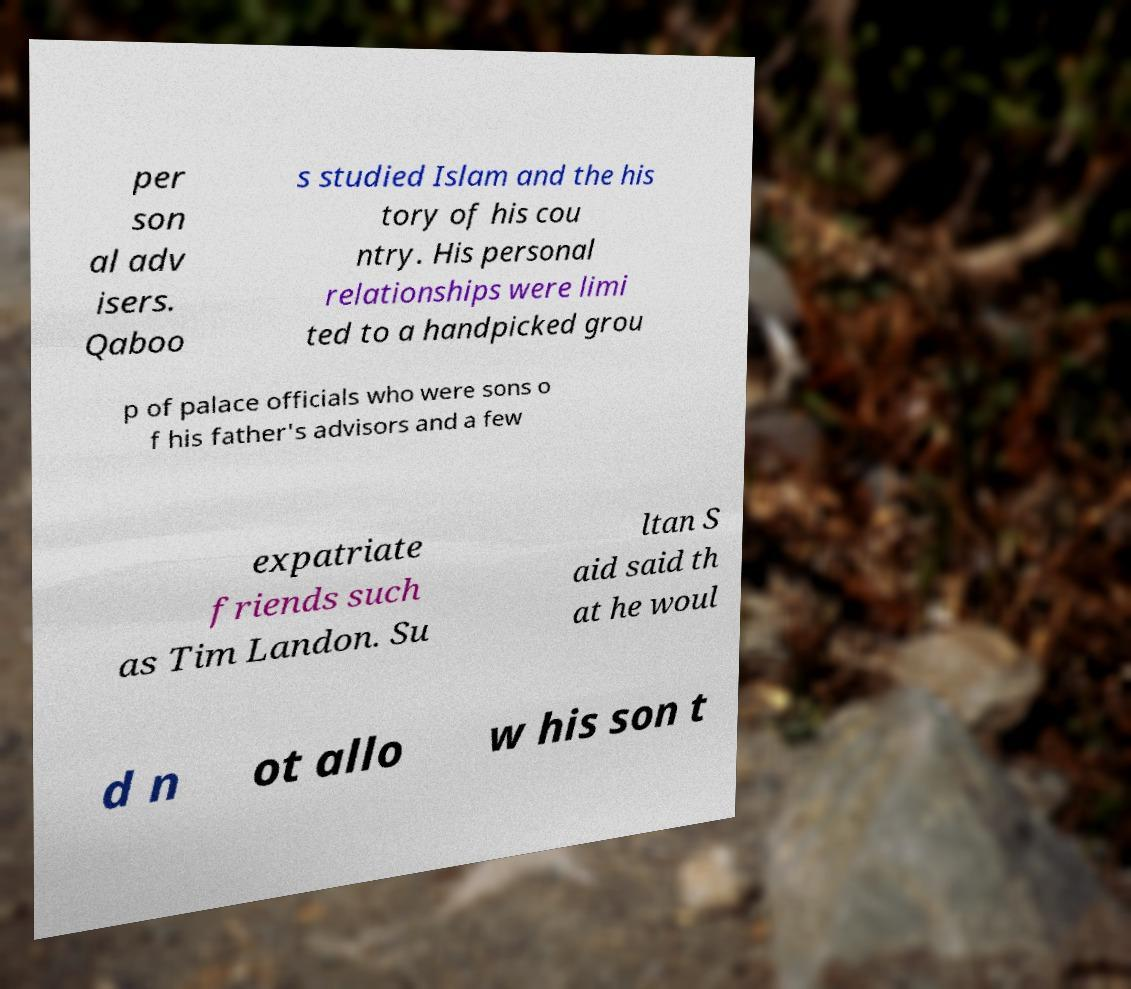For documentation purposes, I need the text within this image transcribed. Could you provide that? per son al adv isers. Qaboo s studied Islam and the his tory of his cou ntry. His personal relationships were limi ted to a handpicked grou p of palace officials who were sons o f his father's advisors and a few expatriate friends such as Tim Landon. Su ltan S aid said th at he woul d n ot allo w his son t 